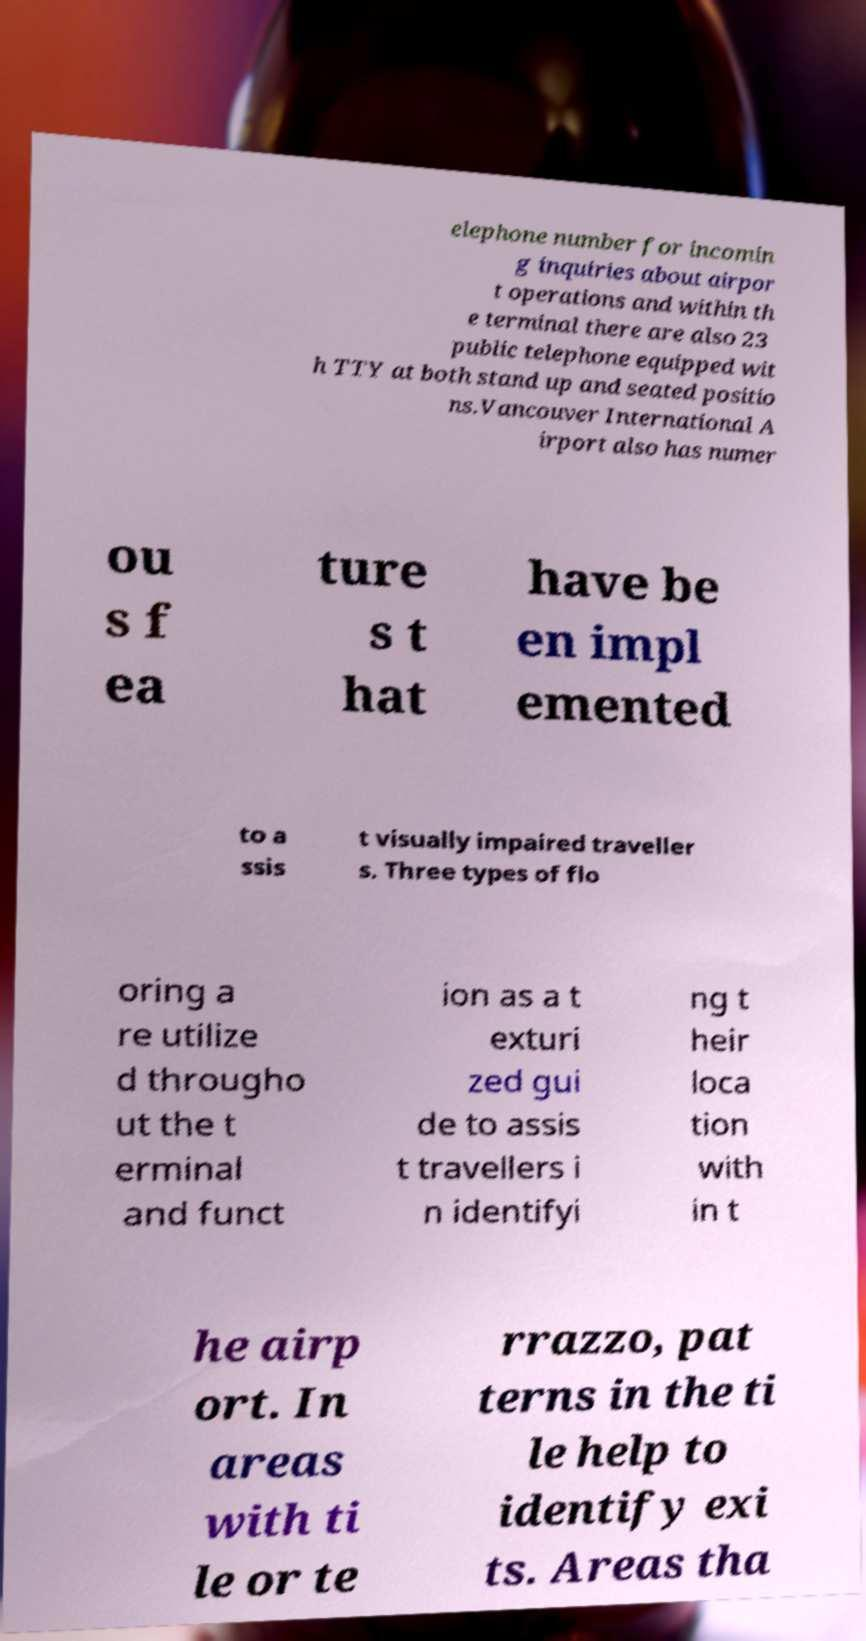Please identify and transcribe the text found in this image. elephone number for incomin g inquiries about airpor t operations and within th e terminal there are also 23 public telephone equipped wit h TTY at both stand up and seated positio ns.Vancouver International A irport also has numer ou s f ea ture s t hat have be en impl emented to a ssis t visually impaired traveller s. Three types of flo oring a re utilize d througho ut the t erminal and funct ion as a t exturi zed gui de to assis t travellers i n identifyi ng t heir loca tion with in t he airp ort. In areas with ti le or te rrazzo, pat terns in the ti le help to identify exi ts. Areas tha 